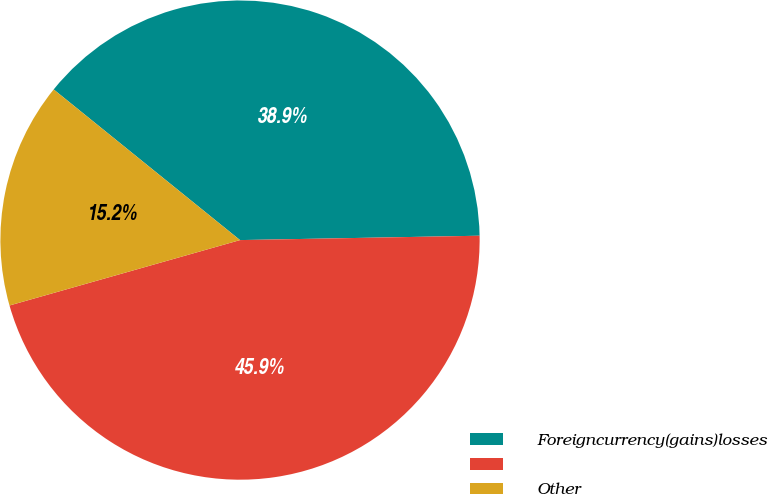<chart> <loc_0><loc_0><loc_500><loc_500><pie_chart><fcel>Foreigncurrency(gains)losses<fcel>Unnamed: 1<fcel>Other<nl><fcel>38.89%<fcel>45.89%<fcel>15.22%<nl></chart> 